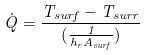<formula> <loc_0><loc_0><loc_500><loc_500>\dot { Q } = \frac { T _ { s u r f } - T _ { s u r r } } { ( \frac { 1 } { h _ { r } A _ { s u r f } } ) }</formula> 